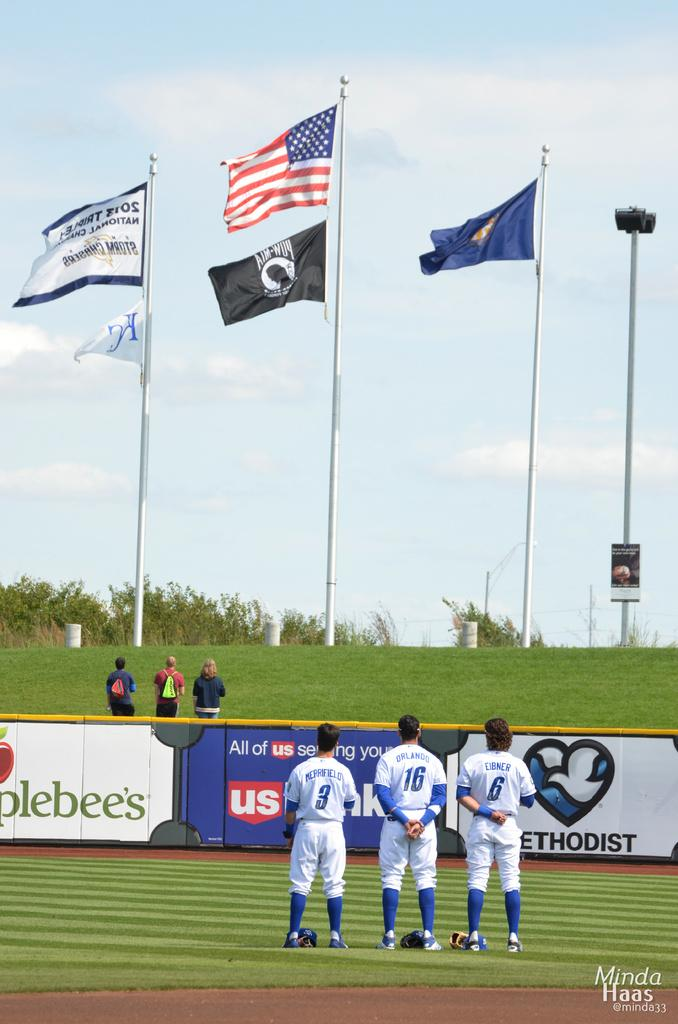Provide a one-sentence caption for the provided image. Baseball players wearing the numbers 3, 16 and 6 gather in the outfield to honor the United States of America. 